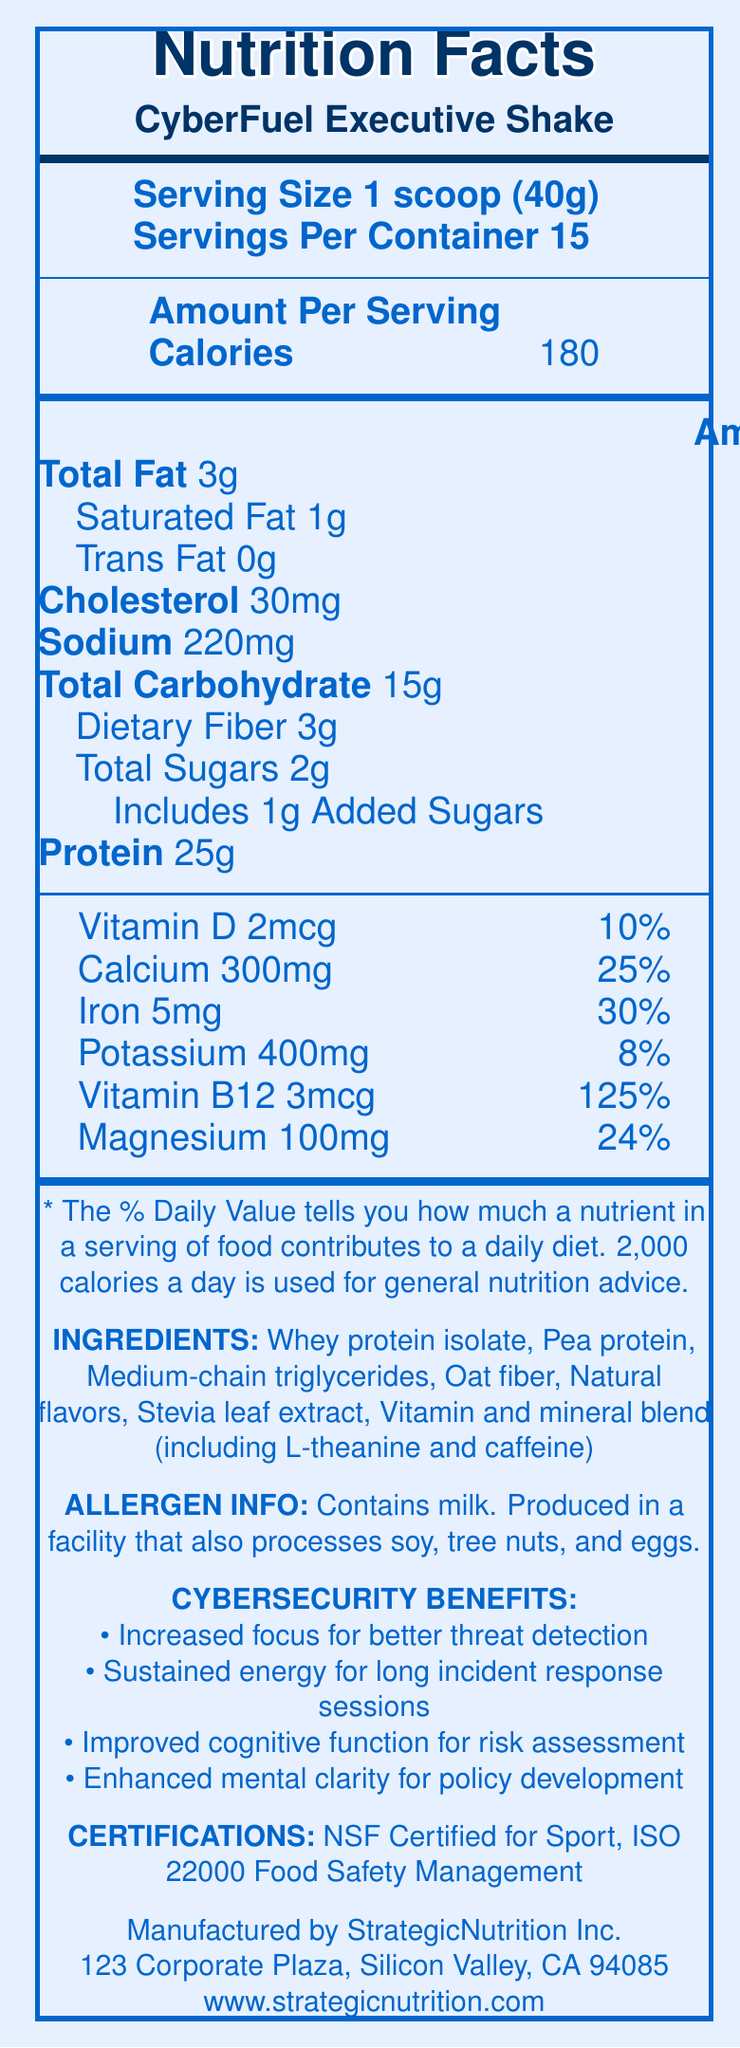what is the serving size of the CyberFuel Executive Shake? The serving size is explicitly mentioned as "1 scoop (40g)" in the nutritional information segment of the document.
Answer: 1 scoop (40g) how many calories are in a single serving of CyberFuel Executive Shake? The calories per serving are stated as 180 in the document.
Answer: 180 what percentage of the daily value of protein is provided by the CyberFuel Executive Shake? The document lists that a single serving provides 25g of protein, which is 50% of the daily value.
Answer: 50% what are the main ingredients in the CyberFuel Executive Shake? These ingredients are listed under the "INGREDIENTS" section of the document.
Answer: Whey protein isolate, Pea protein, Medium-chain triglycerides, Oat fiber, Natural flavors, Stevia leaf extract, Vitamin and mineral blend (including L-theanine and caffeine) list some certifications that the CyberFuel Executive Shake has obtained. The certifications are clearly mentioned in the "CERTIFICATIONS" section of the document.
Answer: NSF Certified for Sport, ISO 22000 Food Safety Management which vitamin has the greatest percentage of daily value in the CyberFuel Executive Shake? A. Vitamin D B. Calcium C. Iron D. Vitamin B12 The document states that Vitamin B12 provides 125% of the daily value, which is the highest among the listed vitamins and minerals.
Answer: D. Vitamin B12 what is the total fat content per serving and its corresponding daily value percentage? The document indicates that the CyberFuel Executive Shake contains 3g of total fat, which is 4% of the daily value.
Answer: 3g, 4% can the CyberFuel Executive Shake be consumed by someone with a soy allergy? The document states that the shake is produced in a facility that also processes soy, indicating potential cross-contamination risks.
Answer: No is there any added sugar in the CyberFuel Executive Shake? There is 1g of added sugars in a serving, which accounts for 2% of the daily value.
Answer: Yes describe the main benefits of consuming the CyberFuel Executive Shake in the context of cybersecurity. The document outlines these specific cybersecurity benefits, emphasizing how the shake aids in complex tasks related to cybersecurity.
Answer: The shake offers increased focus for better threat detection, sustained energy for long incident response sessions, improved cognitive function for risk assessment, and enhanced mental clarity for policy development. who is the manufacturer of the CyberFuel Executive Shake, and where is their address? This information is found in the "Manufactured by" section at the bottom of the document.
Answer: StrategicNutrition Inc., 123 Corporate Plaza, Silicon Valley, CA 94085 what are the total carbohydrate and dietary fiber contents per serving? The nutrient table lists these values under their respective categories.
Answer: 15g total carbohydrate, 3g dietary fiber how much caffeine is in a serving of the CyberFuel Executive Shake? The document mentions "Vitamin and mineral blend (including L-theanine and caffeine)" but does not specify the exact amount of caffeine.
Answer: Not enough information does the CyberFuel Executive Shake contribute to vitamin B12 intake? A. Yes B. No The nutrient table shows that a serving provides 125% of the daily value for vitamin B12.
Answer: A. Yes summarize the entire document. This summary covers all key elements of the document, including nutritional information, ingredients, benefits, and certifications.
Answer: The document provides the nutritional facts for the "CyberFuel Executive Shake," a high-protein meal replacement aimed at busy executives. It highlights the product's composition, including 25g of protein per serving and various vitamins and minerals. Claims include benefits for cognitive function and overall mental acuity, especially in contexts requiring sustained focus such as cybersecurity. The document also lists allergen information, cybersecurity benefits, certifications, and manufacturer details. 